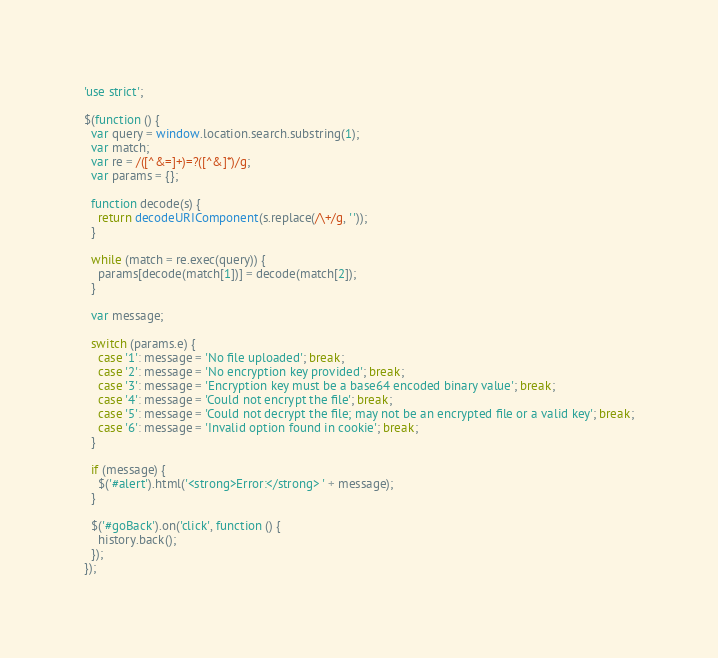Convert code to text. <code><loc_0><loc_0><loc_500><loc_500><_JavaScript_>'use strict';

$(function () {
  var query = window.location.search.substring(1);
  var match;
  var re = /([^&=]+)=?([^&]*)/g;
  var params = {};

  function decode(s) {
    return decodeURIComponent(s.replace(/\+/g, ' '));
  }

  while (match = re.exec(query)) {
    params[decode(match[1])] = decode(match[2]);
  }

  var message;

  switch (params.e) {
    case '1': message = 'No file uploaded'; break;
    case '2': message = 'No encryption key provided'; break;
    case '3': message = 'Encryption key must be a base64 encoded binary value'; break;
    case '4': message = 'Could not encrypt the file'; break;
    case '5': message = 'Could not decrypt the file; may not be an encrypted file or a valid key'; break;
    case '6': message = 'Invalid option found in cookie'; break;
  }

  if (message) {
    $('#alert').html('<strong>Error:</strong> ' + message);
  }

  $('#goBack').on('click', function () {
    history.back();
  });
});
</code> 